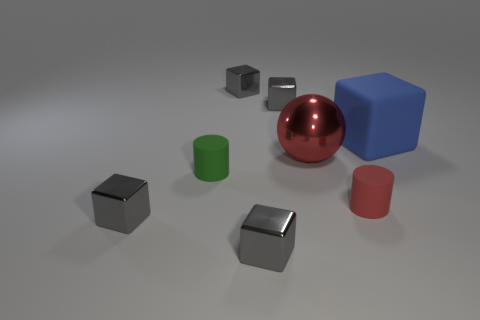Subtract all gray blocks. How many were subtracted if there are1gray blocks left? 3 Subtract all blue cubes. How many cubes are left? 4 Subtract all blue balls. How many gray cubes are left? 4 Subtract all blue cubes. How many cubes are left? 4 Subtract all blue blocks. Subtract all cyan balls. How many blocks are left? 4 Subtract all balls. How many objects are left? 7 Add 1 small green rubber objects. How many objects exist? 9 Subtract 0 blue balls. How many objects are left? 8 Subtract all blue matte blocks. Subtract all matte things. How many objects are left? 4 Add 1 big balls. How many big balls are left? 2 